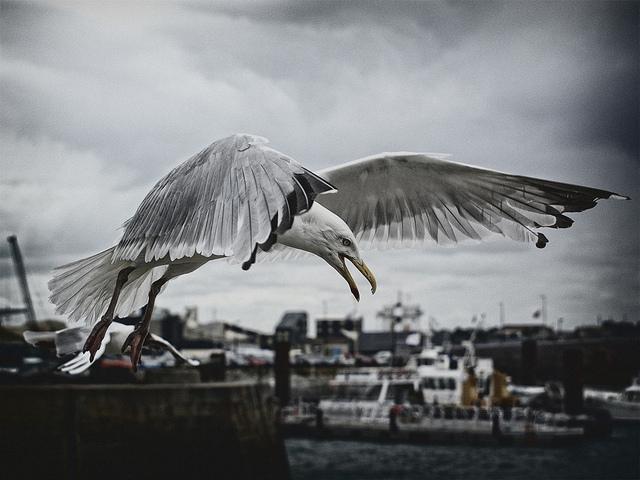Is this bird ready to fly?
Give a very brief answer. Yes. Is it a sunny day?
Answer briefly. No. Is this a black and white or color photo?
Give a very brief answer. Color. 